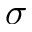<formula> <loc_0><loc_0><loc_500><loc_500>\sigma</formula> 